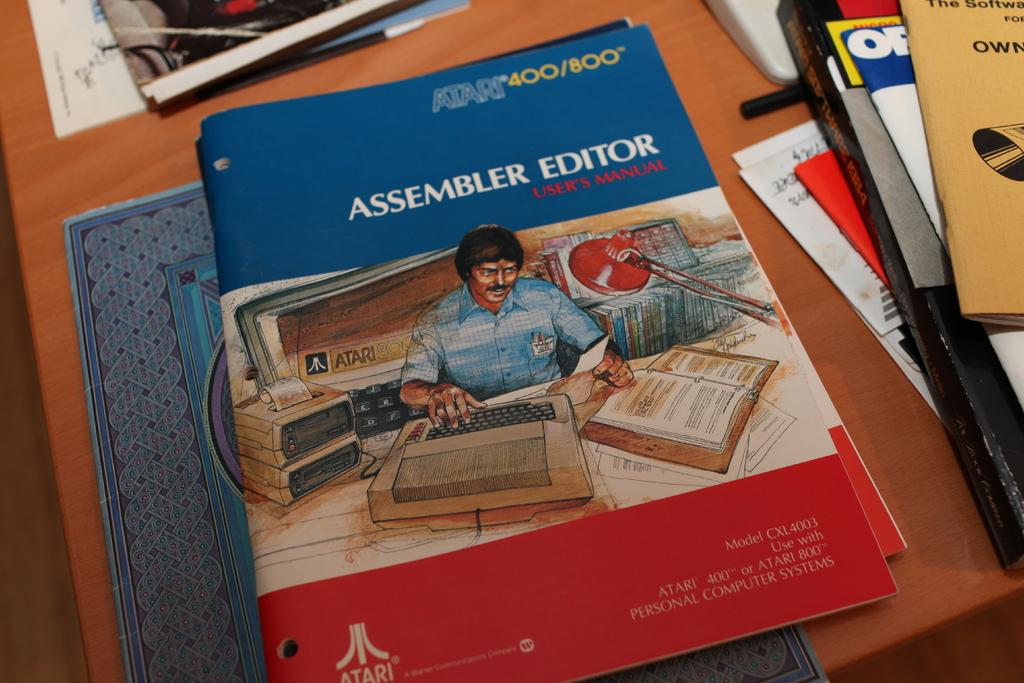What brand of typewriter is this guide used for?
Your answer should be very brief. Atari. What model number is the manual for?
Provide a succinct answer. 400/800. 